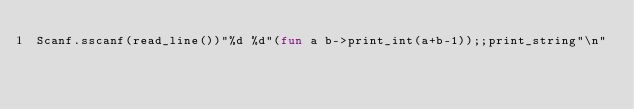Convert code to text. <code><loc_0><loc_0><loc_500><loc_500><_OCaml_>Scanf.sscanf(read_line())"%d %d"(fun a b->print_int(a+b-1));;print_string"\n"</code> 